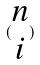Convert formula to latex. <formula><loc_0><loc_0><loc_500><loc_500>( \begin{matrix} n \\ i \end{matrix} )</formula> 